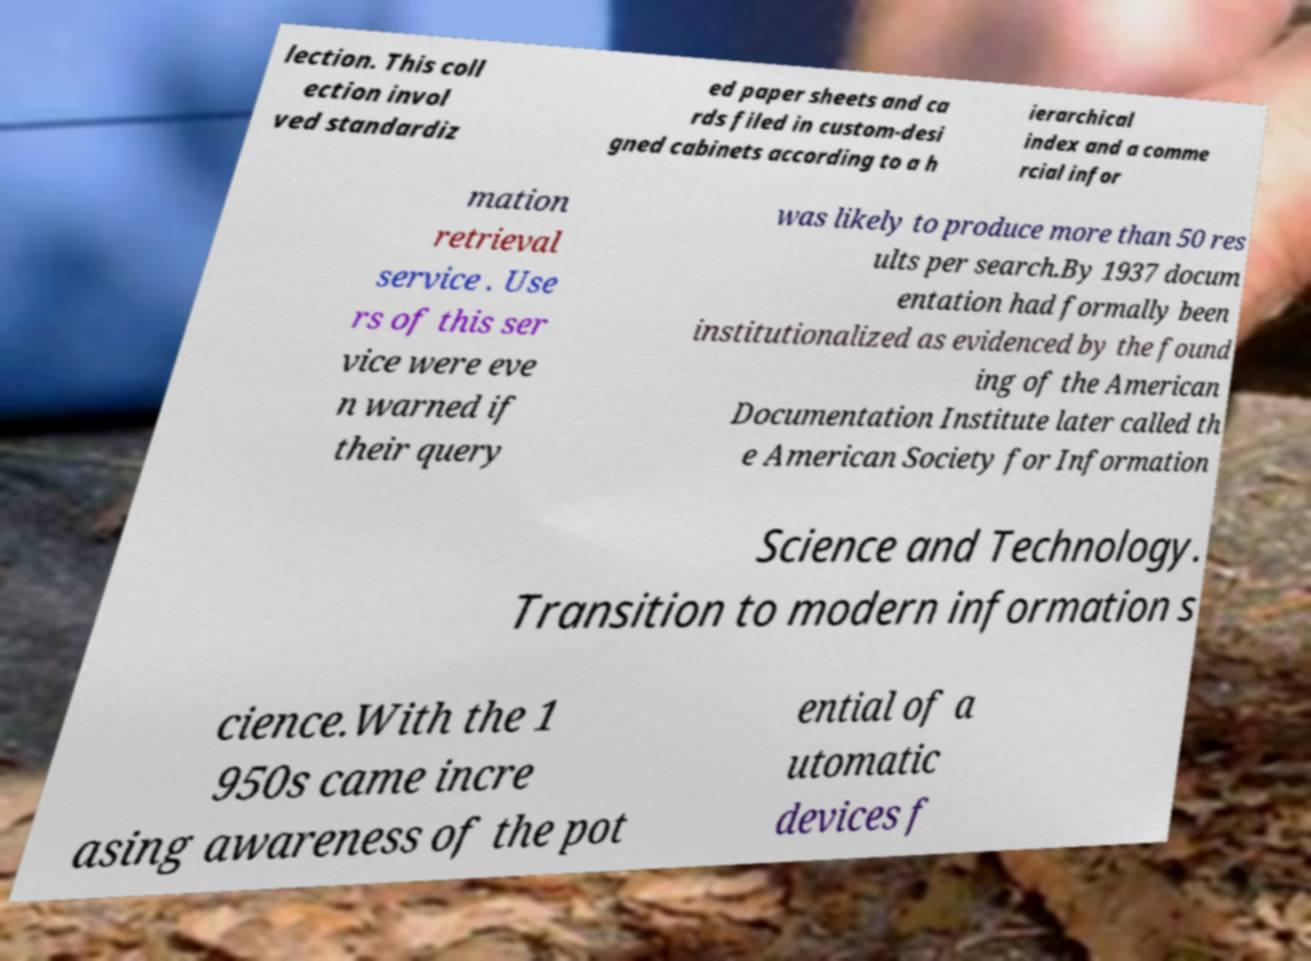Please read and relay the text visible in this image. What does it say? lection. This coll ection invol ved standardiz ed paper sheets and ca rds filed in custom-desi gned cabinets according to a h ierarchical index and a comme rcial infor mation retrieval service . Use rs of this ser vice were eve n warned if their query was likely to produce more than 50 res ults per search.By 1937 docum entation had formally been institutionalized as evidenced by the found ing of the American Documentation Institute later called th e American Society for Information Science and Technology. Transition to modern information s cience.With the 1 950s came incre asing awareness of the pot ential of a utomatic devices f 